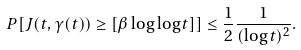Convert formula to latex. <formula><loc_0><loc_0><loc_500><loc_500>P [ J ( t , \gamma ( t ) ) \geq [ \beta \log \log t ] ] \leq \frac { 1 } { 2 } \frac { 1 } { ( \log t ) ^ { 2 } } .</formula> 